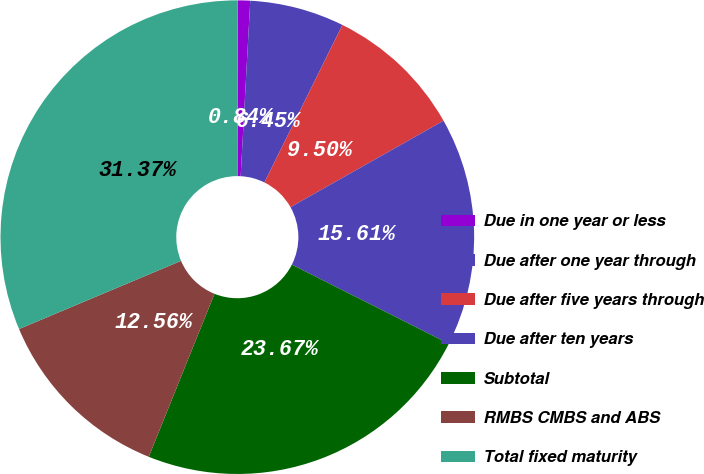Convert chart to OTSL. <chart><loc_0><loc_0><loc_500><loc_500><pie_chart><fcel>Due in one year or less<fcel>Due after one year through<fcel>Due after five years through<fcel>Due after ten years<fcel>Subtotal<fcel>RMBS CMBS and ABS<fcel>Total fixed maturity<nl><fcel>0.84%<fcel>6.45%<fcel>9.5%<fcel>15.61%<fcel>23.67%<fcel>12.56%<fcel>31.37%<nl></chart> 